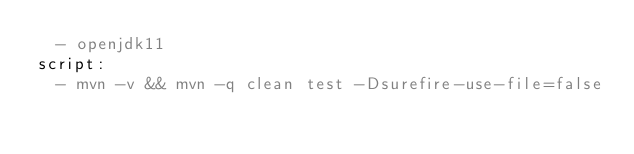<code> <loc_0><loc_0><loc_500><loc_500><_YAML_>  - openjdk11
script:
  - mvn -v && mvn -q clean test -Dsurefire-use-file=false
</code> 